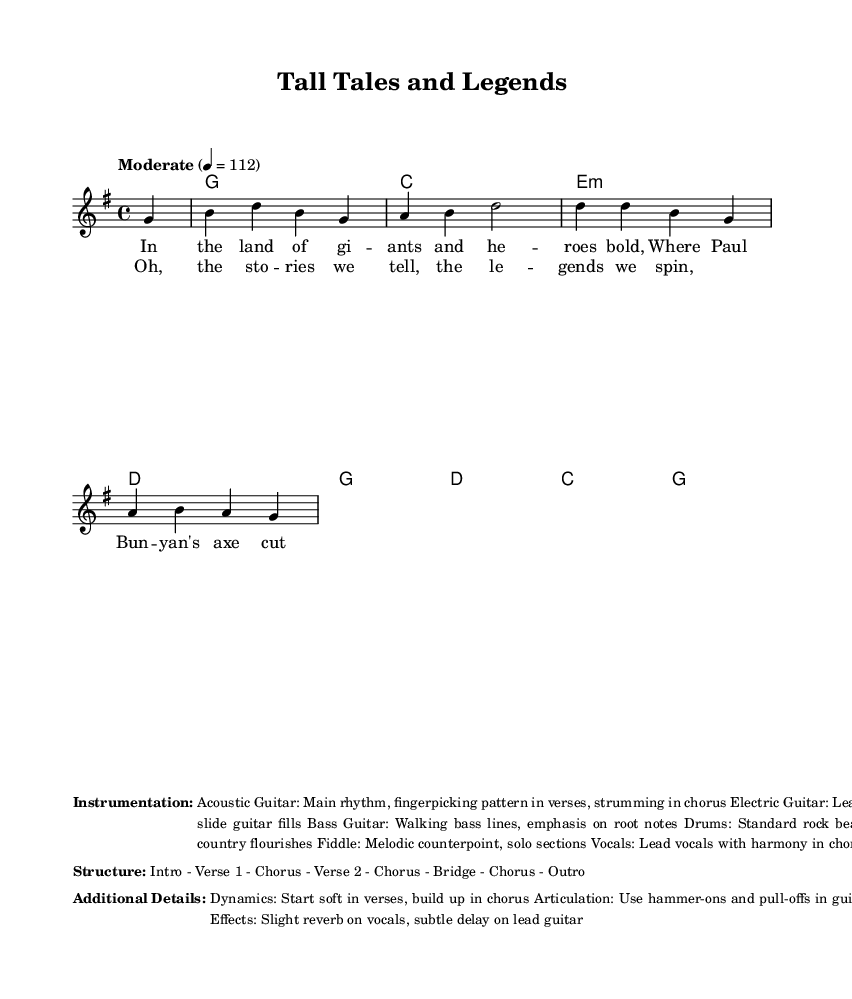What is the key signature of this music? The key signature is G major, indicated by one sharp (F#). This can be determined by looking at the key signature in the beginning of the score.
Answer: G major What is the time signature? The time signature is four-four, indicated by the "4/4" at the beginning of the sheet music. This tells us that there are four beats in each measure and the quarter note gets the beat.
Answer: 4/4 What is the tempo marking? The tempo marking is "Moderate," with a specific tempo of quarter note equals 112. This indicates the speed at which the piece should be performed.
Answer: Moderate How many verses are there in the structure? The structure mentions "Verse 1" and "Verse 2," indicating that there are two verses in this piece. This can be confirmed by analyzing the aforementioned structure listed in the sheet music.
Answer: 2 What role does the fiddle play in the instrumentation? The fiddle adds melodic counterpoint and features in solo sections, enhancing the narrative quality that is characteristic of country rock music. By examining the instrumentation section, we see the specific mention of the fiddle's role.
Answer: Melodic counterpoint Which instrument is primarily responsible for the rhythmic foundation in verses? The acoustic guitar is stated to provide the main rhythm through fingerpicking patterns in the verses, as specified in the instrumentation details. By checking the information provided, we can confirm its role.
Answer: Acoustic Guitar What is the function of the dynamics in the piece? The dynamics begin soft in the verses and build up in the chorus, creating a contrast that enhances the storytelling aspect of the music. This can be inferred from the additional details mentioned regarding dynamics.
Answer: Build up 